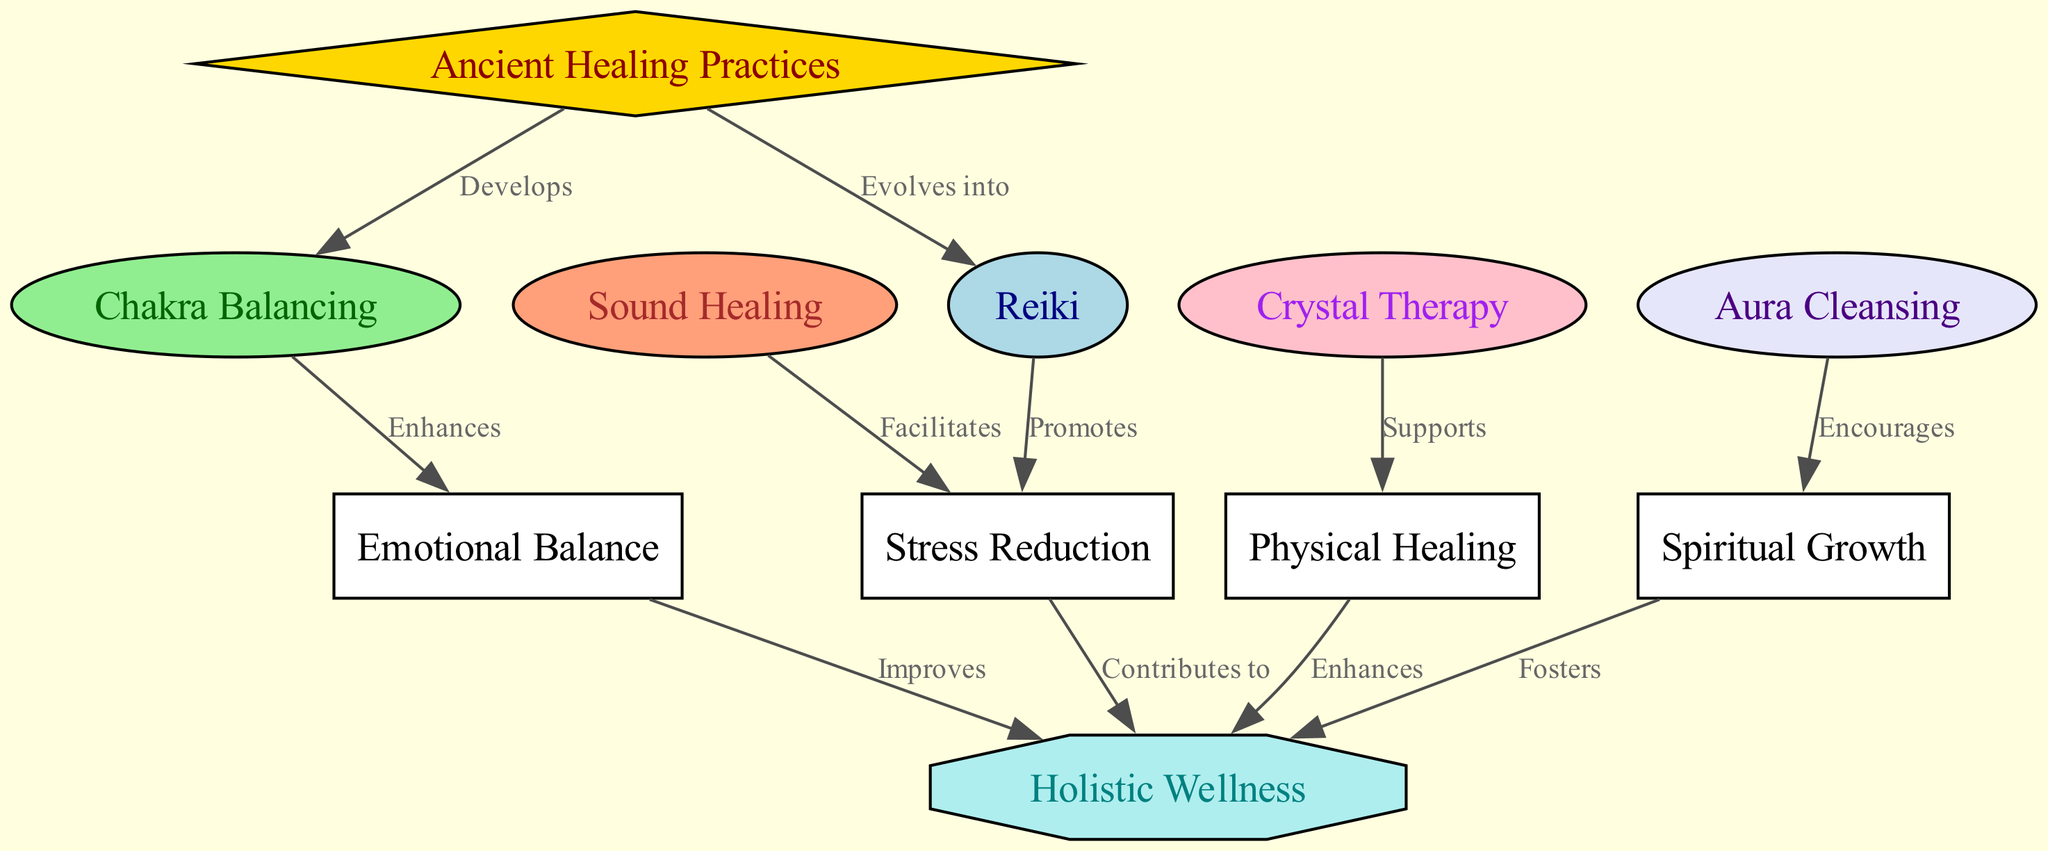What is the total number of nodes in the diagram? The diagram contains a list of nodes that are counted to find the total. The nodes here are: Ancient Healing Practices, Reiki, Chakra Balancing, Crystal Therapy, Sound Healing, Aura Cleansing, Holistic Wellness, Stress Reduction, Emotional Balance, Physical Healing, and Spiritual Growth. Counting these nodes results in a total of 11.
Answer: 11 Which technique evolves from Ancient Healing Practices? The diagram indicates the relationship between Ancient Healing Practices and its subsequent techniques. It specifies that Reiki evolves from Ancient Healing Practices as indicated by the directed edge labeled "Evolves into."
Answer: Reiki What impact does Chakra Balancing have on Emotional Balance? The diagram shows the enhancement relationship between Chakra Balancing and Emotional Balance. It indicates that Chakra Balancing enhances Emotional Balance, which is clearly labeled in the directed edge in the diagram.
Answer: Enhances How many edges show a direct impact on Holistic Wellness? To determine the number of edges leading to Holistic Wellness, we need to examine how many nodes have a directed edge pointing to it. In this diagram, the indicated edges are from Stress Reduction, Emotional Balance, Physical Healing, and Spiritual Growth. Counting these results in 4 edges impacting Holistic Wellness.
Answer: 4 Which healing technique supports Physical Healing? The directed graph shows a connection between Crystal Therapy and Physical Healing. The label identifies that Crystal Therapy supports Physical Healing. Thus, it can be directly answered from the diagram.
Answer: Crystal Therapy What is the relationship between Sound Healing and Stress Reduction? In the directed graph, the relationship is indicated as a facilitative one, meaning Sound Healing facilitates Stress Reduction. This is demonstrated by the directed edge labeled "Facilitates."
Answer: Facilitates How does Spiritual Growth contribute to Holistic Wellness? In the diagram, there is a directed edge from Spiritual Growth to Holistic Wellness labeled "Fosters." This indicates that Spiritual Growth plays a contributory role in achieving Holistic Wellness, demonstrating a positive relationship.
Answer: Fosters List the techniques that promote stress reduction. The diagram shows two techniques that have a direct impact on Stress Reduction: Reiki and Sound Healing. Both techniques are indicated as promoting or facilitating Stress Reduction through their respective edges.
Answer: Reiki, Sound Healing 